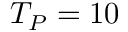<formula> <loc_0><loc_0><loc_500><loc_500>T _ { P } = 1 0</formula> 